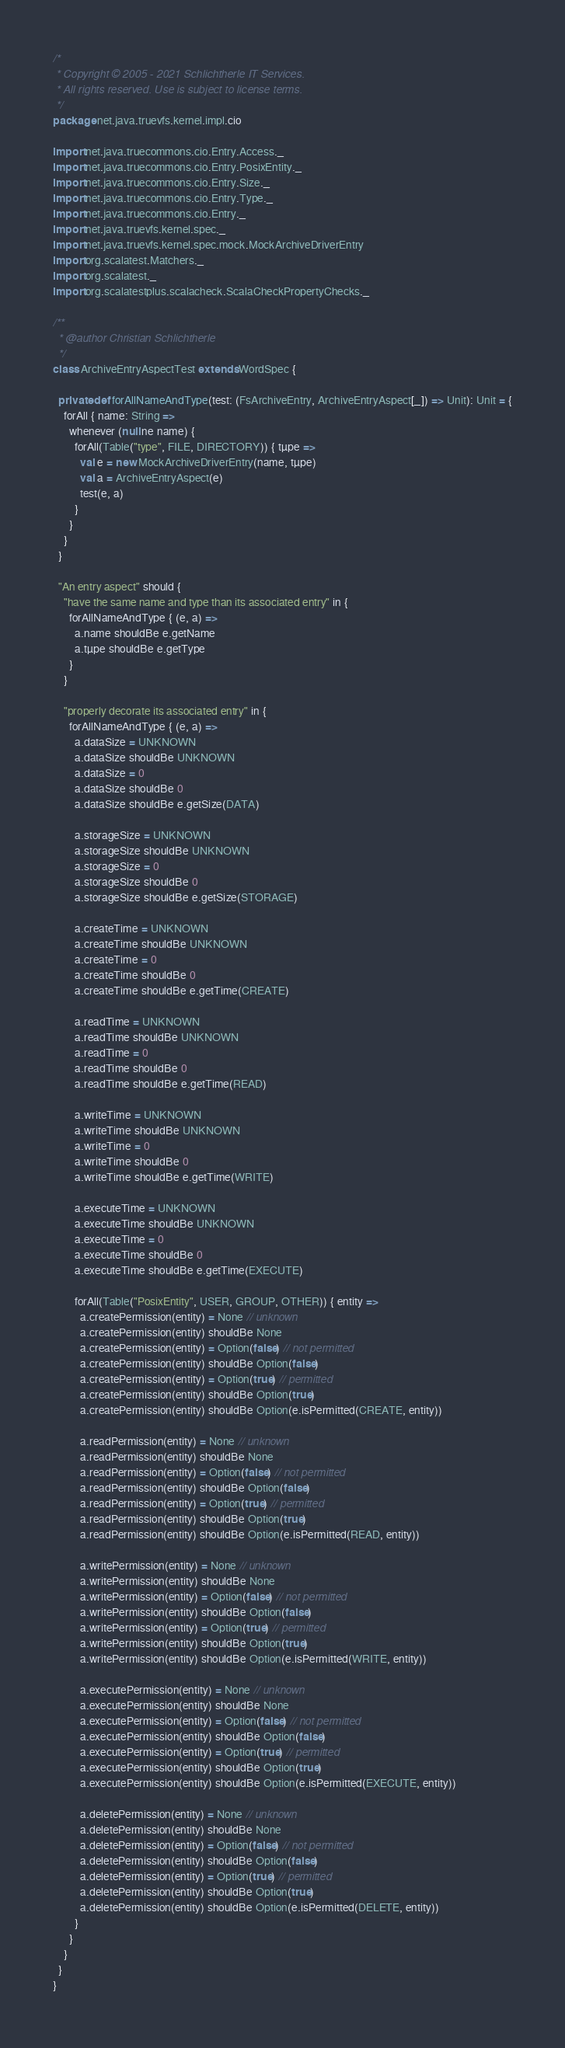<code> <loc_0><loc_0><loc_500><loc_500><_Scala_>/*
 * Copyright © 2005 - 2021 Schlichtherle IT Services.
 * All rights reserved. Use is subject to license terms.
 */
package net.java.truevfs.kernel.impl.cio

import net.java.truecommons.cio.Entry.Access._
import net.java.truecommons.cio.Entry.PosixEntity._
import net.java.truecommons.cio.Entry.Size._
import net.java.truecommons.cio.Entry.Type._
import net.java.truecommons.cio.Entry._
import net.java.truevfs.kernel.spec._
import net.java.truevfs.kernel.spec.mock.MockArchiveDriverEntry
import org.scalatest.Matchers._
import org.scalatest._
import org.scalatestplus.scalacheck.ScalaCheckPropertyChecks._

/**
  * @author Christian Schlichtherle
  */
class ArchiveEntryAspectTest extends WordSpec {

  private def forAllNameAndType(test: (FsArchiveEntry, ArchiveEntryAspect[_]) => Unit): Unit = {
    forAll { name: String =>
      whenever (null ne name) {
        forAll(Table("type", FILE, DIRECTORY)) { tµpe =>
          val e = new MockArchiveDriverEntry(name, tµpe)
          val a = ArchiveEntryAspect(e)
          test(e, a)
        }
      }
    }
  }

  "An entry aspect" should {
    "have the same name and type than its associated entry" in {
      forAllNameAndType { (e, a) =>
        a.name shouldBe e.getName
        a.tµpe shouldBe e.getType
      }
    }

    "properly decorate its associated entry" in {
      forAllNameAndType { (e, a) =>
        a.dataSize = UNKNOWN
        a.dataSize shouldBe UNKNOWN
        a.dataSize = 0
        a.dataSize shouldBe 0
        a.dataSize shouldBe e.getSize(DATA)

        a.storageSize = UNKNOWN
        a.storageSize shouldBe UNKNOWN
        a.storageSize = 0
        a.storageSize shouldBe 0
        a.storageSize shouldBe e.getSize(STORAGE)

        a.createTime = UNKNOWN
        a.createTime shouldBe UNKNOWN
        a.createTime = 0
        a.createTime shouldBe 0
        a.createTime shouldBe e.getTime(CREATE)

        a.readTime = UNKNOWN
        a.readTime shouldBe UNKNOWN
        a.readTime = 0
        a.readTime shouldBe 0
        a.readTime shouldBe e.getTime(READ)

        a.writeTime = UNKNOWN
        a.writeTime shouldBe UNKNOWN
        a.writeTime = 0
        a.writeTime shouldBe 0
        a.writeTime shouldBe e.getTime(WRITE)

        a.executeTime = UNKNOWN
        a.executeTime shouldBe UNKNOWN
        a.executeTime = 0
        a.executeTime shouldBe 0
        a.executeTime shouldBe e.getTime(EXECUTE)

        forAll(Table("PosixEntity", USER, GROUP, OTHER)) { entity =>
          a.createPermission(entity) = None // unknown
          a.createPermission(entity) shouldBe None
          a.createPermission(entity) = Option(false) // not permitted
          a.createPermission(entity) shouldBe Option(false)
          a.createPermission(entity) = Option(true) // permitted
          a.createPermission(entity) shouldBe Option(true)
          a.createPermission(entity) shouldBe Option(e.isPermitted(CREATE, entity))

          a.readPermission(entity) = None // unknown
          a.readPermission(entity) shouldBe None
          a.readPermission(entity) = Option(false) // not permitted
          a.readPermission(entity) shouldBe Option(false)
          a.readPermission(entity) = Option(true) // permitted
          a.readPermission(entity) shouldBe Option(true)
          a.readPermission(entity) shouldBe Option(e.isPermitted(READ, entity))

          a.writePermission(entity) = None // unknown
          a.writePermission(entity) shouldBe None
          a.writePermission(entity) = Option(false) // not permitted
          a.writePermission(entity) shouldBe Option(false)
          a.writePermission(entity) = Option(true) // permitted
          a.writePermission(entity) shouldBe Option(true)
          a.writePermission(entity) shouldBe Option(e.isPermitted(WRITE, entity))

          a.executePermission(entity) = None // unknown
          a.executePermission(entity) shouldBe None
          a.executePermission(entity) = Option(false) // not permitted
          a.executePermission(entity) shouldBe Option(false)
          a.executePermission(entity) = Option(true) // permitted
          a.executePermission(entity) shouldBe Option(true)
          a.executePermission(entity) shouldBe Option(e.isPermitted(EXECUTE, entity))

          a.deletePermission(entity) = None // unknown
          a.deletePermission(entity) shouldBe None
          a.deletePermission(entity) = Option(false) // not permitted
          a.deletePermission(entity) shouldBe Option(false)
          a.deletePermission(entity) = Option(true) // permitted
          a.deletePermission(entity) shouldBe Option(true)
          a.deletePermission(entity) shouldBe Option(e.isPermitted(DELETE, entity))
        }
      }
    }
  }
}
</code> 